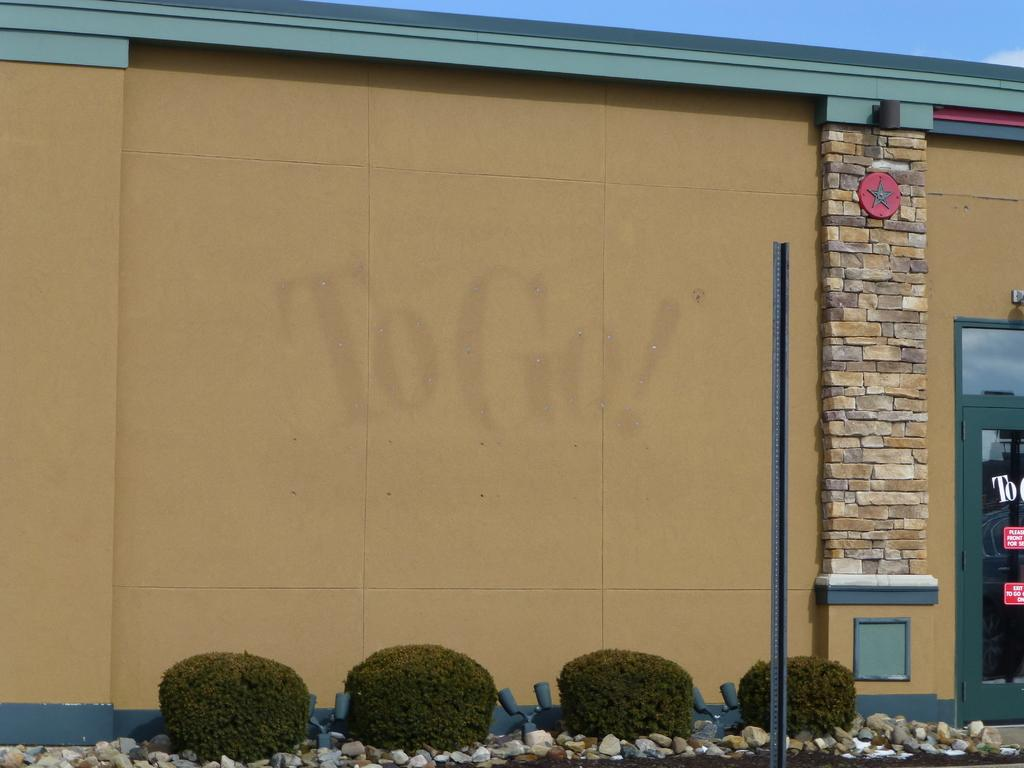What structure can be seen in the image? There is a pole in the image. What type of vegetation is present in the image? There are bushes in the image. What type of material is present in the image? There are stones in the image. What type of entrance is visible in the image? There is a glass door in the image. What type of man-made structure is present in the image? There is a building in the image. What part of the natural environment is visible in the image? The sky is visible behind the building. What type of church can be seen in the image? There is no church present in the image. How many cannons are visible in the image? There are no cannons present in the image. 